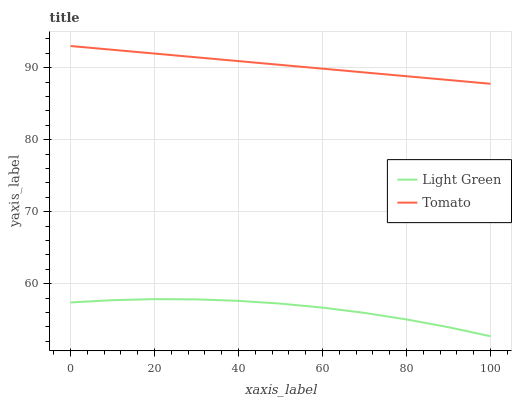Does Light Green have the minimum area under the curve?
Answer yes or no. Yes. Does Tomato have the maximum area under the curve?
Answer yes or no. Yes. Does Light Green have the maximum area under the curve?
Answer yes or no. No. Is Tomato the smoothest?
Answer yes or no. Yes. Is Light Green the roughest?
Answer yes or no. Yes. Is Light Green the smoothest?
Answer yes or no. No. Does Light Green have the highest value?
Answer yes or no. No. Is Light Green less than Tomato?
Answer yes or no. Yes. Is Tomato greater than Light Green?
Answer yes or no. Yes. Does Light Green intersect Tomato?
Answer yes or no. No. 